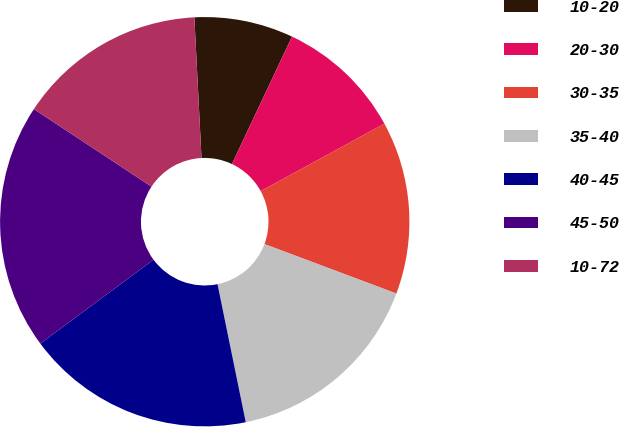<chart> <loc_0><loc_0><loc_500><loc_500><pie_chart><fcel>10-20<fcel>20-30<fcel>30-35<fcel>35-40<fcel>40-45<fcel>45-50<fcel>10-72<nl><fcel>7.82%<fcel>10.04%<fcel>13.66%<fcel>16.08%<fcel>18.06%<fcel>19.43%<fcel>14.92%<nl></chart> 